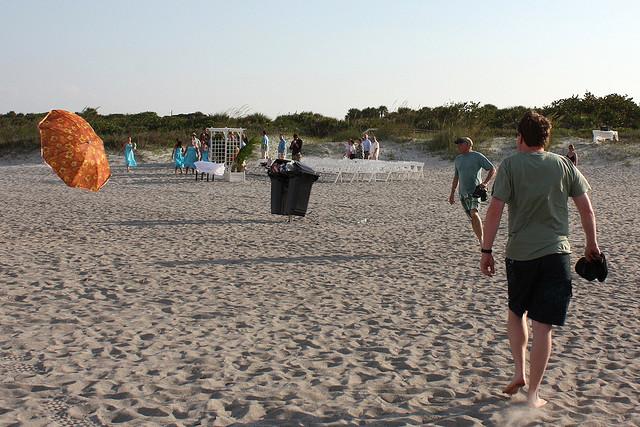Is the orange umbrella open?
Answer briefly. Yes. What kind of event is happening in the background?
Short answer required. Wedding. Is the garbage full?
Quick response, please. Yes. 